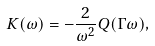<formula> <loc_0><loc_0><loc_500><loc_500>K ( \omega ) = - \frac { 2 } { \omega ^ { 2 } } Q ( \Gamma \omega ) ,</formula> 